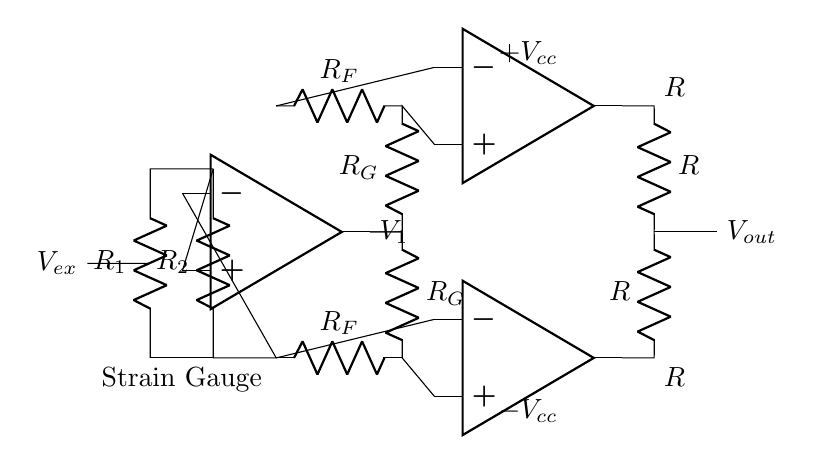What type of amplifier is used in this circuit? The circuit demonstrates an instrumentation amplifier, which is identified by its use of multiple operational amplifiers and resistors designed for precise measurements in low-level signals.
Answer: instrumentation amplifier What components are present in the input stage? The input stage contains two resistors labeled R1 and R2, which correspond to the strain gauge used to sense deformation.
Answer: R1 and R2 What is the purpose of the resistors R_F in this configuration? Resistors R_F are used in the feedback loop of the operational amplifiers, which contributes to the gain and stability of the amplifier, thus enhancing the measurement of strain.
Answer: gain and stability How many operational amplifiers are utilized in this circuit? The circuit uses three operational amplifiers, indicated by the icons labeled op amp along the signal path.
Answer: three What is the output voltage denoted as in the circuit? The output voltage is clearly labeled at the output node and identified as V_out, indicating the voltage level that results from the amplified input signal.
Answer: V_out What role does the strain gauge play in this circuit? The strain gauge measures the amount of deformation in the material being tested, producing a differential voltage that the instrumentation amplifier amplifies for further analysis.
Answer: measures deformation What is the expected effect of using an instrumentation amplifier for strain gauge signals? An instrumentation amplifier enhances the weak signals from the strain gauge, improving signal-to-noise ratio and accuracy in the measurement of strain, essential for reliable material testing.
Answer: enhances weak signals 